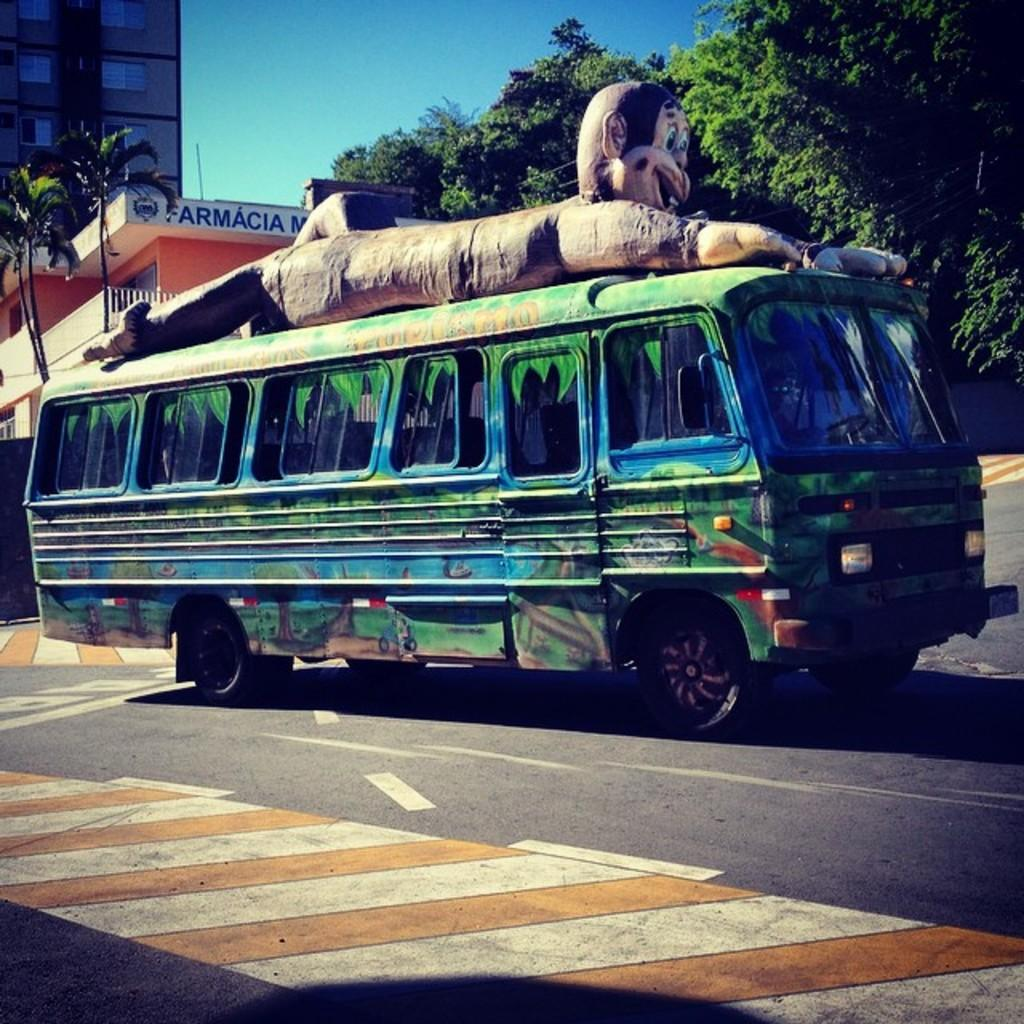What type of vehicle is on the road in the image? There is a bus on the road in the image. What can be seen behind the bus in the image? There are trees and buildings behind the bus in the image. Can you read any names or signs on the buildings in the image? Yes, there is a name on one of the buildings in the image. What type of ink is used to write the name on the building in the image? There is no indication of the type of ink used to write the name on the building in the image. Additionally, the image does not show any ink. 